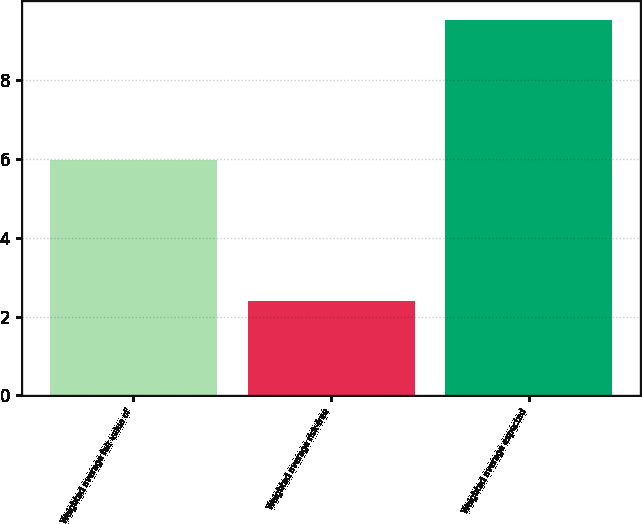Convert chart to OTSL. <chart><loc_0><loc_0><loc_500><loc_500><bar_chart><fcel>Weighted average fair value of<fcel>Weighted average risk-free<fcel>Weighted average expected<nl><fcel>5.96<fcel>2.4<fcel>9.52<nl></chart> 